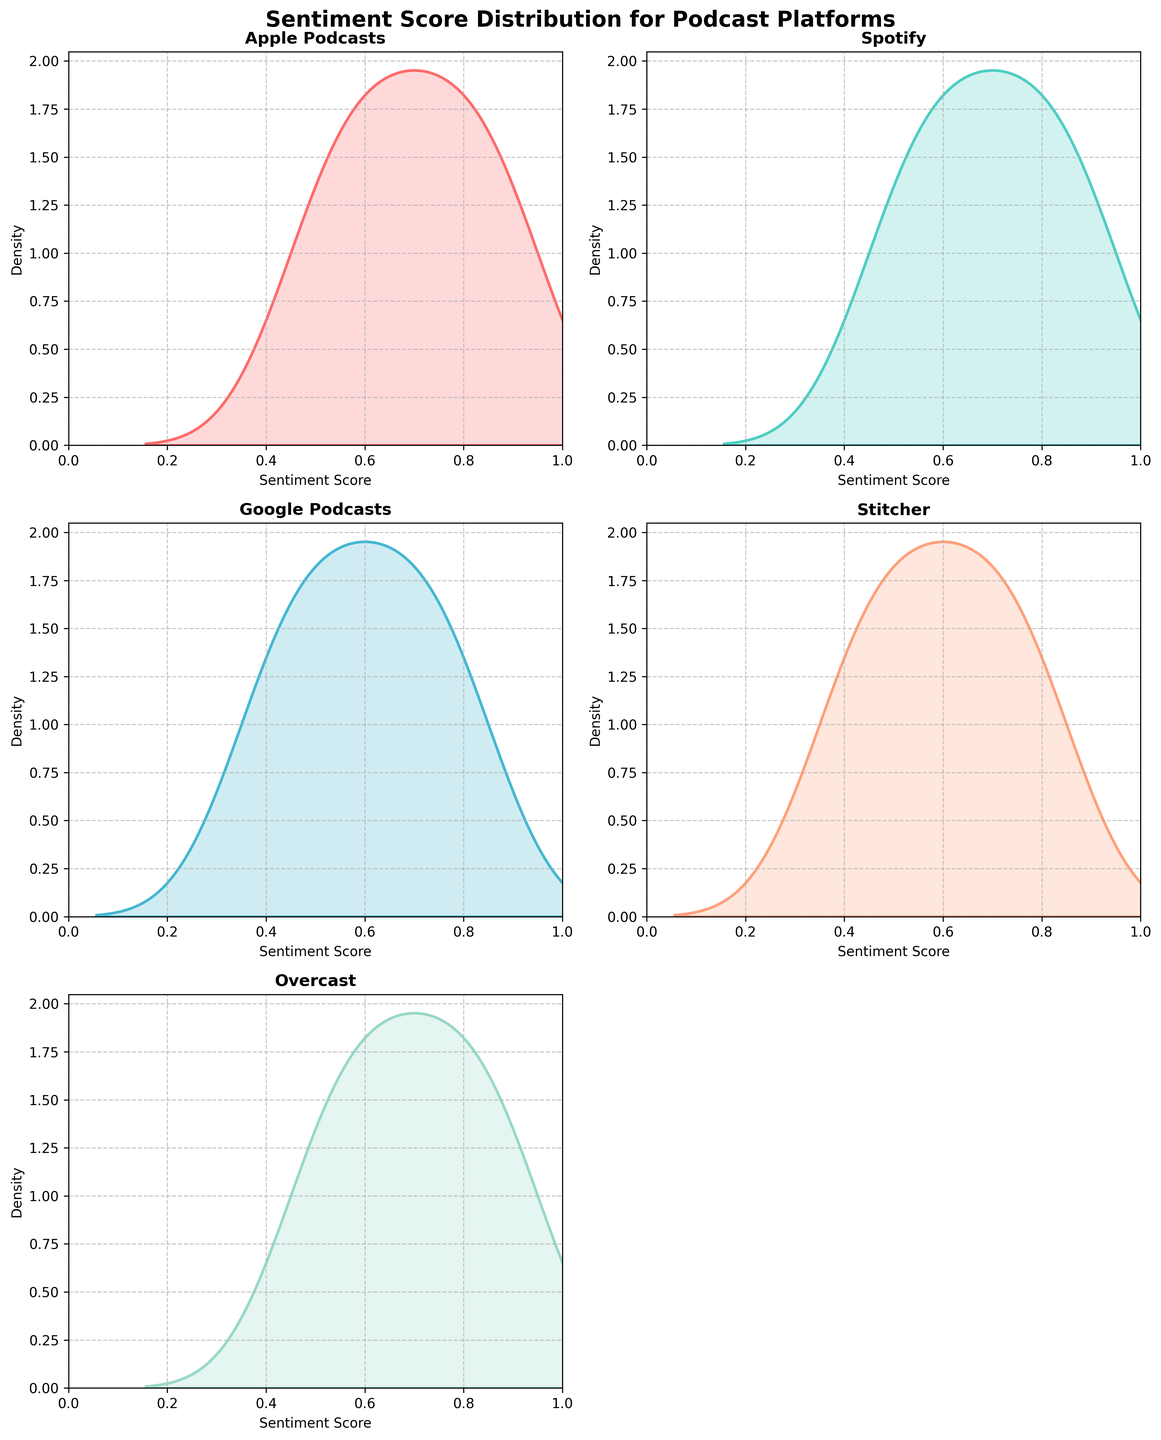What is the title of the figure? The title of the figure can be found at the top of the plot, which is "Sentiment Score Distribution for Podcast Platforms".
Answer: Sentiment Score Distribution for Podcast Platforms Which platform's sentiment score distribution plot is located in the top-left plot? We can see that the top-left plot is the first subplot shown. It is labeled with the platform name, which is "Apple Podcasts".
Answer: Apple Podcasts What are the x-axis limits for the sentiment score plots? By observing the x-axis in any of the subplots, we notice that the x-axis ranges from 0 to 1.
Answer: 0 to 1 Which platform has a sentiment score plot colored in light turquoise? By checking the color assigned to each platform, we can see that light turquoise is used for "Spotify".
Answer: Spotify Which platform shows the widest spread in sentiment scores? The density plot with the widest spread will have the flattest appearance, so we look for the plot where the density is spread across the widest range of the x-axis. Google Podcasts seem to have the most spread.
Answer: Google Podcasts Compare the peak density of Apple Podcasts and Overcast. Which is higher? To determine this, we compare the maximum density values in the density plots for Apple Podcasts and Overcast. Overcast has a higher peak density than Apple Podcasts.
Answer: Overcast On which platform do we see the lowest sentiment score, and what is the approximate value? By observing the x-axis and density row closely for the smallest value, Stitcher's plot shows a sentiment score reaching down to approximately 0.4.
Answer: Stitcher, 0.4 What do the areas under the density plots represent? Each density plot represents the distribution of sentiment scores for a platform. The area under each plot is equal to 1, representing the entire dataset's probability distribution.
Answer: Distribution of sentiment scores, area under the plot is 1 Which platform's sentiment score has the narrowest density peak and what does this imply? The plot with the narrowest density peak will have the highest peak in a small x-range. Overcast's plot illustrates this, implying most scores are centered around a specific value.
Answer: Overcast Do any platforms show a multimodal distribution in their sentiment scores? A multimodal distribution has multiple peaks. By examining the plots, none of the platforms shows distinct multiple peaks, indicating no multimodal distribution.
Answer: No 